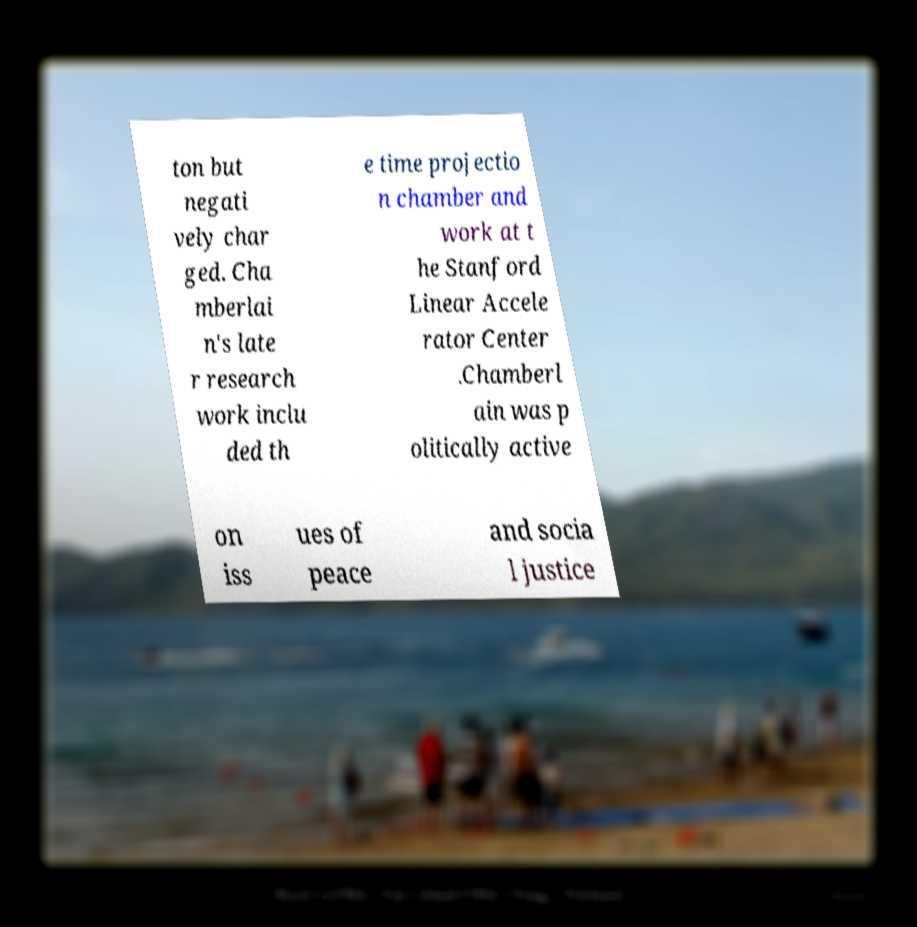Please identify and transcribe the text found in this image. ton but negati vely char ged. Cha mberlai n's late r research work inclu ded th e time projectio n chamber and work at t he Stanford Linear Accele rator Center .Chamberl ain was p olitically active on iss ues of peace and socia l justice 